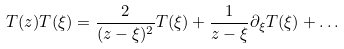Convert formula to latex. <formula><loc_0><loc_0><loc_500><loc_500>T ( z ) T ( \xi ) = \frac { 2 } { ( z - \xi ) ^ { 2 } } T ( \xi ) + \frac { 1 } { z - \xi } \partial _ { \xi } T ( \xi ) + \dots</formula> 